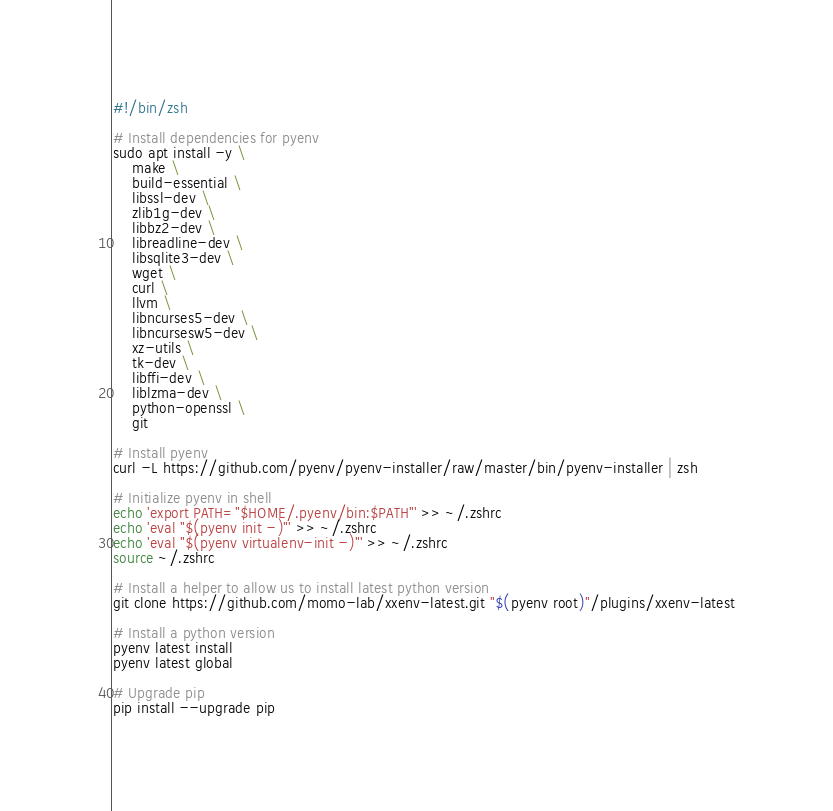Convert code to text. <code><loc_0><loc_0><loc_500><loc_500><_Bash_>#!/bin/zsh

# Install dependencies for pyenv
sudo apt install -y \
    make \
    build-essential \
    libssl-dev \
    zlib1g-dev \
    libbz2-dev \
    libreadline-dev \
    libsqlite3-dev \
    wget \
    curl \
    llvm \
    libncurses5-dev \
    libncursesw5-dev \
    xz-utils \
    tk-dev \
    libffi-dev \
    liblzma-dev \
    python-openssl \
    git

# Install pyenv
curl -L https://github.com/pyenv/pyenv-installer/raw/master/bin/pyenv-installer | zsh

# Initialize pyenv in shell
echo 'export PATH="$HOME/.pyenv/bin:$PATH"' >> ~/.zshrc
echo 'eval "$(pyenv init -)"' >> ~/.zshrc
echo 'eval "$(pyenv virtualenv-init -)"' >> ~/.zshrc
source ~/.zshrc

# Install a helper to allow us to install latest python version
git clone https://github.com/momo-lab/xxenv-latest.git "$(pyenv root)"/plugins/xxenv-latest

# Install a python version
pyenv latest install
pyenv latest global

# Upgrade pip
pip install --upgrade pip
</code> 